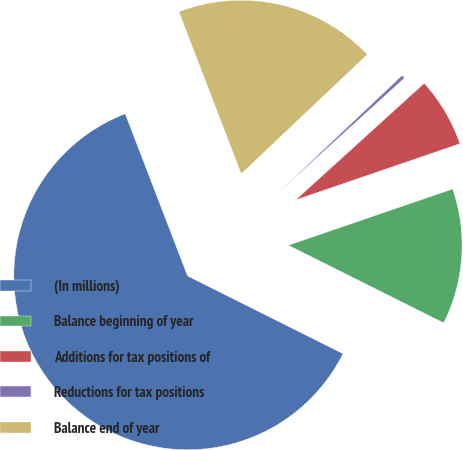<chart> <loc_0><loc_0><loc_500><loc_500><pie_chart><fcel>(In millions)<fcel>Balance beginning of year<fcel>Additions for tax positions of<fcel>Reductions for tax positions<fcel>Balance end of year<nl><fcel>61.78%<fcel>12.63%<fcel>6.48%<fcel>0.34%<fcel>18.77%<nl></chart> 